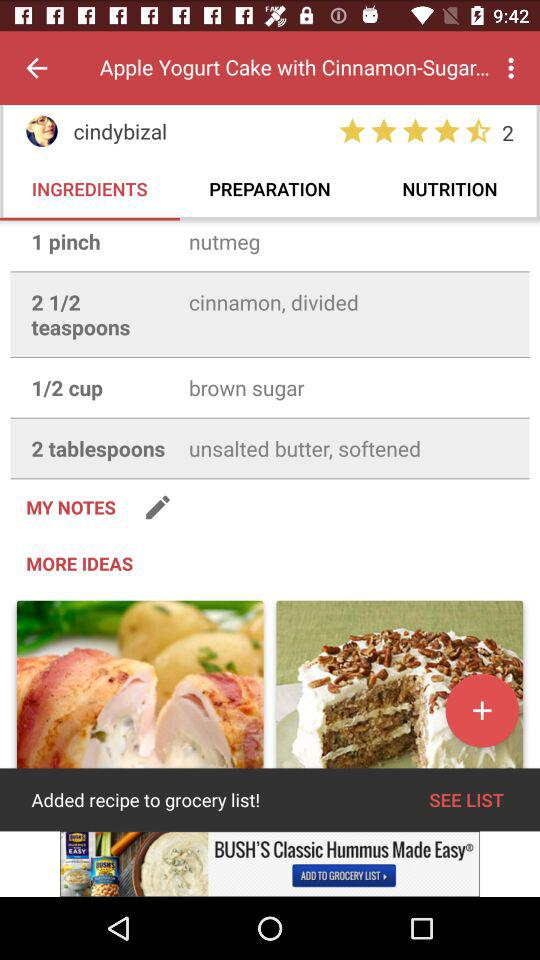How many tablespoons of "unsalted butter" are needed in the recipe posted by "cindybizal"? There is a need for 2 tablespoons of "unsalted butter" in the recipe posted by "cindybizal". 